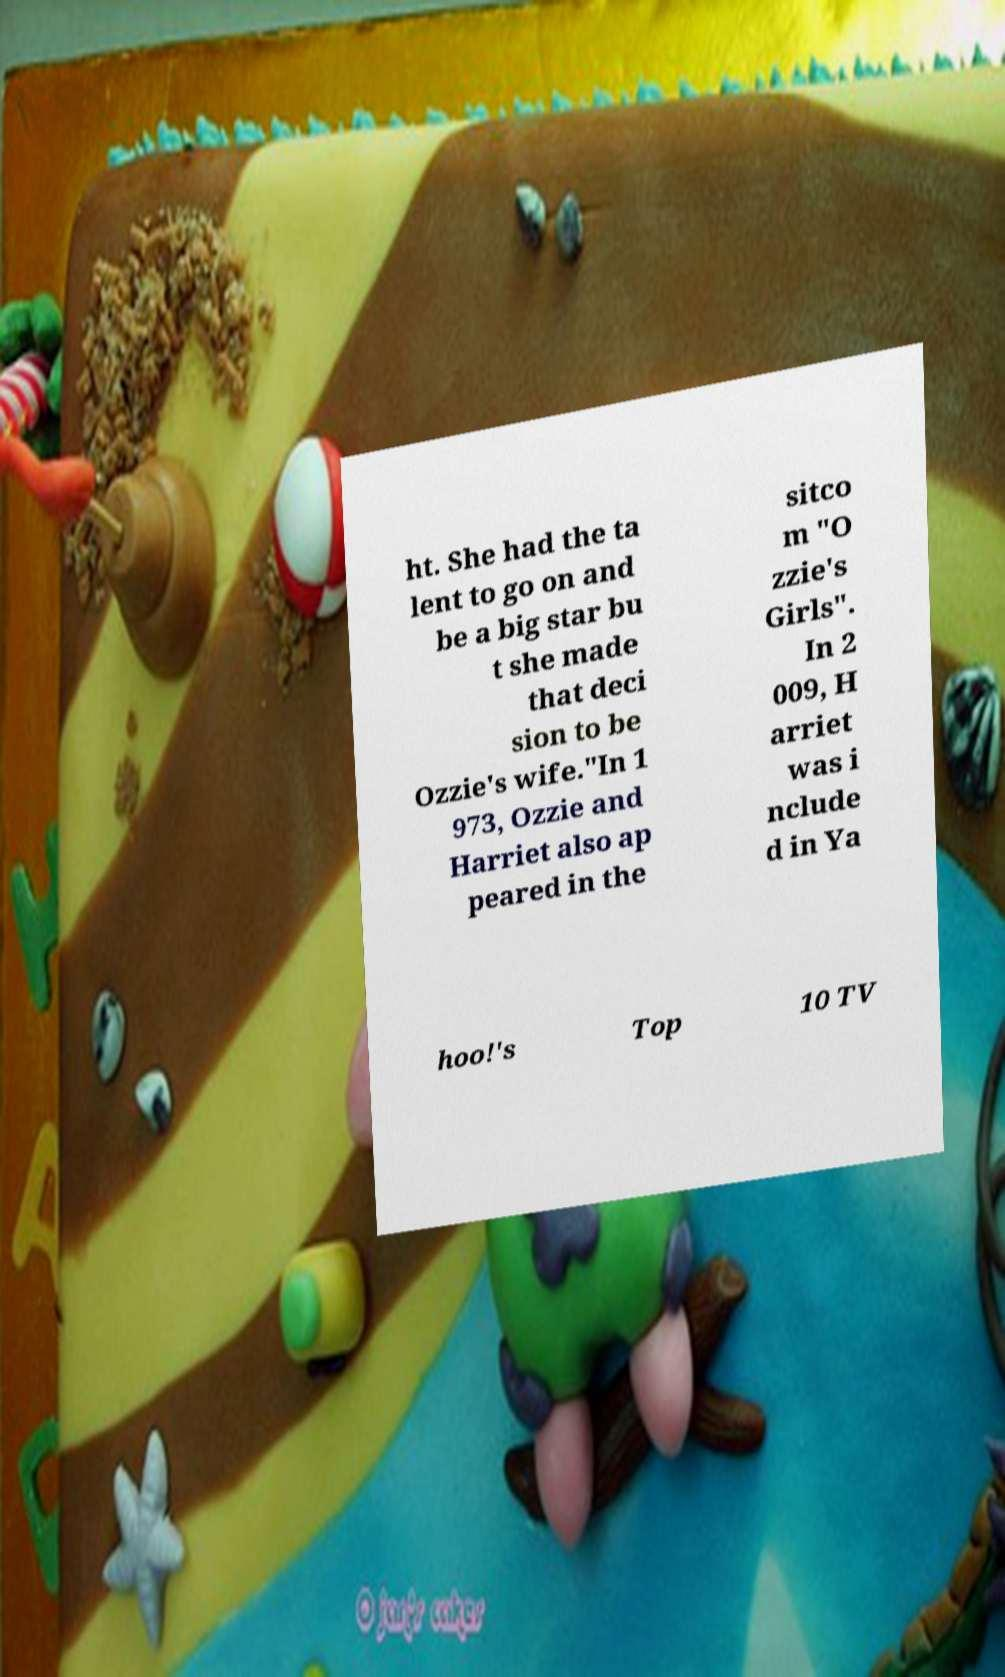There's text embedded in this image that I need extracted. Can you transcribe it verbatim? ht. She had the ta lent to go on and be a big star bu t she made that deci sion to be Ozzie's wife."In 1 973, Ozzie and Harriet also ap peared in the sitco m "O zzie's Girls". In 2 009, H arriet was i nclude d in Ya hoo!'s Top 10 TV 